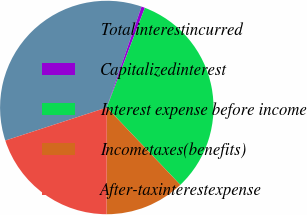Convert chart to OTSL. <chart><loc_0><loc_0><loc_500><loc_500><pie_chart><fcel>Totalinterestincurred<fcel>Capitalizedinterest<fcel>Interest expense before income<fcel>Incometaxes(benefits)<fcel>After-taxinterestexpense<nl><fcel>35.29%<fcel>0.53%<fcel>32.09%<fcel>12.12%<fcel>19.96%<nl></chart> 